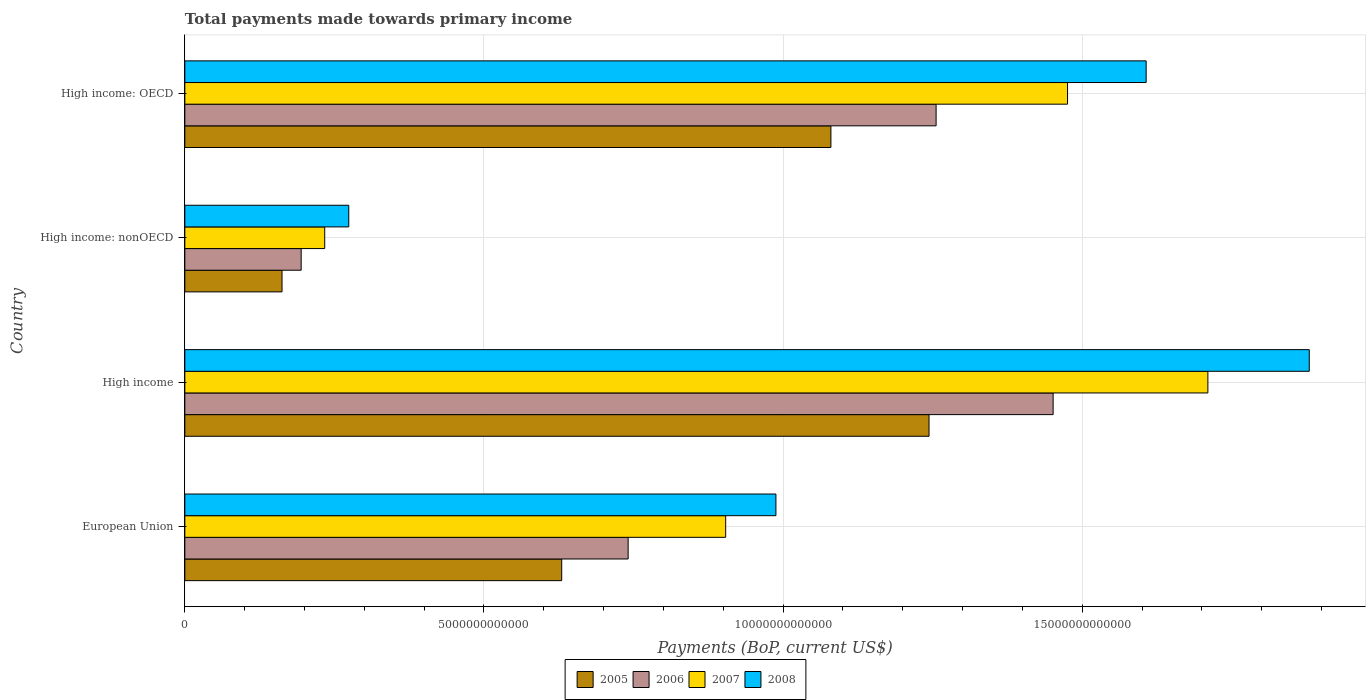How many different coloured bars are there?
Make the answer very short. 4. How many bars are there on the 3rd tick from the bottom?
Your answer should be compact. 4. What is the label of the 3rd group of bars from the top?
Your response must be concise. High income. What is the total payments made towards primary income in 2006 in High income: OECD?
Give a very brief answer. 1.26e+13. Across all countries, what is the maximum total payments made towards primary income in 2006?
Keep it short and to the point. 1.45e+13. Across all countries, what is the minimum total payments made towards primary income in 2008?
Ensure brevity in your answer.  2.74e+12. In which country was the total payments made towards primary income in 2007 minimum?
Make the answer very short. High income: nonOECD. What is the total total payments made towards primary income in 2005 in the graph?
Keep it short and to the point. 3.12e+13. What is the difference between the total payments made towards primary income in 2005 in European Union and that in High income: nonOECD?
Make the answer very short. 4.67e+12. What is the difference between the total payments made towards primary income in 2005 in High income: OECD and the total payments made towards primary income in 2008 in High income: nonOECD?
Offer a terse response. 8.06e+12. What is the average total payments made towards primary income in 2005 per country?
Ensure brevity in your answer.  7.79e+12. What is the difference between the total payments made towards primary income in 2006 and total payments made towards primary income in 2008 in European Union?
Provide a succinct answer. -2.47e+12. What is the ratio of the total payments made towards primary income in 2005 in European Union to that in High income?
Offer a very short reply. 0.51. Is the difference between the total payments made towards primary income in 2006 in High income and High income: OECD greater than the difference between the total payments made towards primary income in 2008 in High income and High income: OECD?
Your answer should be very brief. No. What is the difference between the highest and the second highest total payments made towards primary income in 2006?
Offer a very short reply. 1.96e+12. What is the difference between the highest and the lowest total payments made towards primary income in 2005?
Offer a very short reply. 1.08e+13. What does the 3rd bar from the bottom in High income represents?
Your response must be concise. 2007. How many bars are there?
Ensure brevity in your answer.  16. Are all the bars in the graph horizontal?
Provide a short and direct response. Yes. What is the difference between two consecutive major ticks on the X-axis?
Provide a short and direct response. 5.00e+12. Does the graph contain any zero values?
Your answer should be compact. No. Does the graph contain grids?
Your answer should be very brief. Yes. How are the legend labels stacked?
Offer a very short reply. Horizontal. What is the title of the graph?
Provide a succinct answer. Total payments made towards primary income. What is the label or title of the X-axis?
Give a very brief answer. Payments (BoP, current US$). What is the label or title of the Y-axis?
Your answer should be compact. Country. What is the Payments (BoP, current US$) of 2005 in European Union?
Your response must be concise. 6.30e+12. What is the Payments (BoP, current US$) of 2006 in European Union?
Keep it short and to the point. 7.41e+12. What is the Payments (BoP, current US$) in 2007 in European Union?
Provide a succinct answer. 9.04e+12. What is the Payments (BoP, current US$) in 2008 in European Union?
Your response must be concise. 9.88e+12. What is the Payments (BoP, current US$) of 2005 in High income?
Offer a terse response. 1.24e+13. What is the Payments (BoP, current US$) in 2006 in High income?
Make the answer very short. 1.45e+13. What is the Payments (BoP, current US$) in 2007 in High income?
Provide a succinct answer. 1.71e+13. What is the Payments (BoP, current US$) of 2008 in High income?
Ensure brevity in your answer.  1.88e+13. What is the Payments (BoP, current US$) in 2005 in High income: nonOECD?
Your response must be concise. 1.62e+12. What is the Payments (BoP, current US$) in 2006 in High income: nonOECD?
Your response must be concise. 1.94e+12. What is the Payments (BoP, current US$) in 2007 in High income: nonOECD?
Keep it short and to the point. 2.34e+12. What is the Payments (BoP, current US$) of 2008 in High income: nonOECD?
Your answer should be compact. 2.74e+12. What is the Payments (BoP, current US$) in 2005 in High income: OECD?
Provide a succinct answer. 1.08e+13. What is the Payments (BoP, current US$) in 2006 in High income: OECD?
Your answer should be compact. 1.26e+13. What is the Payments (BoP, current US$) in 2007 in High income: OECD?
Your answer should be compact. 1.48e+13. What is the Payments (BoP, current US$) of 2008 in High income: OECD?
Your answer should be very brief. 1.61e+13. Across all countries, what is the maximum Payments (BoP, current US$) in 2005?
Your response must be concise. 1.24e+13. Across all countries, what is the maximum Payments (BoP, current US$) in 2006?
Ensure brevity in your answer.  1.45e+13. Across all countries, what is the maximum Payments (BoP, current US$) in 2007?
Make the answer very short. 1.71e+13. Across all countries, what is the maximum Payments (BoP, current US$) in 2008?
Ensure brevity in your answer.  1.88e+13. Across all countries, what is the minimum Payments (BoP, current US$) of 2005?
Give a very brief answer. 1.62e+12. Across all countries, what is the minimum Payments (BoP, current US$) in 2006?
Offer a very short reply. 1.94e+12. Across all countries, what is the minimum Payments (BoP, current US$) of 2007?
Offer a very short reply. 2.34e+12. Across all countries, what is the minimum Payments (BoP, current US$) in 2008?
Your answer should be compact. 2.74e+12. What is the total Payments (BoP, current US$) of 2005 in the graph?
Keep it short and to the point. 3.12e+13. What is the total Payments (BoP, current US$) in 2006 in the graph?
Provide a short and direct response. 3.64e+13. What is the total Payments (BoP, current US$) in 2007 in the graph?
Provide a short and direct response. 4.32e+13. What is the total Payments (BoP, current US$) in 2008 in the graph?
Your answer should be compact. 4.75e+13. What is the difference between the Payments (BoP, current US$) of 2005 in European Union and that in High income?
Keep it short and to the point. -6.14e+12. What is the difference between the Payments (BoP, current US$) in 2006 in European Union and that in High income?
Offer a very short reply. -7.10e+12. What is the difference between the Payments (BoP, current US$) in 2007 in European Union and that in High income?
Your response must be concise. -8.06e+12. What is the difference between the Payments (BoP, current US$) of 2008 in European Union and that in High income?
Keep it short and to the point. -8.91e+12. What is the difference between the Payments (BoP, current US$) of 2005 in European Union and that in High income: nonOECD?
Your answer should be very brief. 4.67e+12. What is the difference between the Payments (BoP, current US$) of 2006 in European Union and that in High income: nonOECD?
Provide a succinct answer. 5.47e+12. What is the difference between the Payments (BoP, current US$) in 2007 in European Union and that in High income: nonOECD?
Offer a terse response. 6.70e+12. What is the difference between the Payments (BoP, current US$) in 2008 in European Union and that in High income: nonOECD?
Offer a very short reply. 7.14e+12. What is the difference between the Payments (BoP, current US$) in 2005 in European Union and that in High income: OECD?
Provide a succinct answer. -4.50e+12. What is the difference between the Payments (BoP, current US$) of 2006 in European Union and that in High income: OECD?
Give a very brief answer. -5.15e+12. What is the difference between the Payments (BoP, current US$) of 2007 in European Union and that in High income: OECD?
Keep it short and to the point. -5.71e+12. What is the difference between the Payments (BoP, current US$) of 2008 in European Union and that in High income: OECD?
Your response must be concise. -6.19e+12. What is the difference between the Payments (BoP, current US$) in 2005 in High income and that in High income: nonOECD?
Ensure brevity in your answer.  1.08e+13. What is the difference between the Payments (BoP, current US$) of 2006 in High income and that in High income: nonOECD?
Provide a short and direct response. 1.26e+13. What is the difference between the Payments (BoP, current US$) in 2007 in High income and that in High income: nonOECD?
Offer a very short reply. 1.48e+13. What is the difference between the Payments (BoP, current US$) in 2008 in High income and that in High income: nonOECD?
Keep it short and to the point. 1.61e+13. What is the difference between the Payments (BoP, current US$) of 2005 in High income and that in High income: OECD?
Your answer should be very brief. 1.64e+12. What is the difference between the Payments (BoP, current US$) of 2006 in High income and that in High income: OECD?
Make the answer very short. 1.96e+12. What is the difference between the Payments (BoP, current US$) in 2007 in High income and that in High income: OECD?
Give a very brief answer. 2.35e+12. What is the difference between the Payments (BoP, current US$) in 2008 in High income and that in High income: OECD?
Provide a short and direct response. 2.73e+12. What is the difference between the Payments (BoP, current US$) of 2005 in High income: nonOECD and that in High income: OECD?
Your response must be concise. -9.17e+12. What is the difference between the Payments (BoP, current US$) in 2006 in High income: nonOECD and that in High income: OECD?
Provide a succinct answer. -1.06e+13. What is the difference between the Payments (BoP, current US$) of 2007 in High income: nonOECD and that in High income: OECD?
Make the answer very short. -1.24e+13. What is the difference between the Payments (BoP, current US$) in 2008 in High income: nonOECD and that in High income: OECD?
Your answer should be compact. -1.33e+13. What is the difference between the Payments (BoP, current US$) of 2005 in European Union and the Payments (BoP, current US$) of 2006 in High income?
Ensure brevity in your answer.  -8.21e+12. What is the difference between the Payments (BoP, current US$) of 2005 in European Union and the Payments (BoP, current US$) of 2007 in High income?
Keep it short and to the point. -1.08e+13. What is the difference between the Payments (BoP, current US$) of 2005 in European Union and the Payments (BoP, current US$) of 2008 in High income?
Offer a very short reply. -1.25e+13. What is the difference between the Payments (BoP, current US$) in 2006 in European Union and the Payments (BoP, current US$) in 2007 in High income?
Offer a terse response. -9.69e+12. What is the difference between the Payments (BoP, current US$) in 2006 in European Union and the Payments (BoP, current US$) in 2008 in High income?
Your answer should be very brief. -1.14e+13. What is the difference between the Payments (BoP, current US$) in 2007 in European Union and the Payments (BoP, current US$) in 2008 in High income?
Offer a very short reply. -9.75e+12. What is the difference between the Payments (BoP, current US$) in 2005 in European Union and the Payments (BoP, current US$) in 2006 in High income: nonOECD?
Your answer should be very brief. 4.35e+12. What is the difference between the Payments (BoP, current US$) of 2005 in European Union and the Payments (BoP, current US$) of 2007 in High income: nonOECD?
Give a very brief answer. 3.96e+12. What is the difference between the Payments (BoP, current US$) in 2005 in European Union and the Payments (BoP, current US$) in 2008 in High income: nonOECD?
Offer a terse response. 3.56e+12. What is the difference between the Payments (BoP, current US$) in 2006 in European Union and the Payments (BoP, current US$) in 2007 in High income: nonOECD?
Ensure brevity in your answer.  5.07e+12. What is the difference between the Payments (BoP, current US$) of 2006 in European Union and the Payments (BoP, current US$) of 2008 in High income: nonOECD?
Ensure brevity in your answer.  4.67e+12. What is the difference between the Payments (BoP, current US$) of 2007 in European Union and the Payments (BoP, current US$) of 2008 in High income: nonOECD?
Make the answer very short. 6.30e+12. What is the difference between the Payments (BoP, current US$) of 2005 in European Union and the Payments (BoP, current US$) of 2006 in High income: OECD?
Your answer should be compact. -6.26e+12. What is the difference between the Payments (BoP, current US$) of 2005 in European Union and the Payments (BoP, current US$) of 2007 in High income: OECD?
Offer a very short reply. -8.45e+12. What is the difference between the Payments (BoP, current US$) in 2005 in European Union and the Payments (BoP, current US$) in 2008 in High income: OECD?
Provide a short and direct response. -9.77e+12. What is the difference between the Payments (BoP, current US$) in 2006 in European Union and the Payments (BoP, current US$) in 2007 in High income: OECD?
Give a very brief answer. -7.34e+12. What is the difference between the Payments (BoP, current US$) of 2006 in European Union and the Payments (BoP, current US$) of 2008 in High income: OECD?
Offer a terse response. -8.66e+12. What is the difference between the Payments (BoP, current US$) in 2007 in European Union and the Payments (BoP, current US$) in 2008 in High income: OECD?
Your response must be concise. -7.03e+12. What is the difference between the Payments (BoP, current US$) in 2005 in High income and the Payments (BoP, current US$) in 2006 in High income: nonOECD?
Keep it short and to the point. 1.05e+13. What is the difference between the Payments (BoP, current US$) of 2005 in High income and the Payments (BoP, current US$) of 2007 in High income: nonOECD?
Offer a very short reply. 1.01e+13. What is the difference between the Payments (BoP, current US$) in 2005 in High income and the Payments (BoP, current US$) in 2008 in High income: nonOECD?
Your response must be concise. 9.70e+12. What is the difference between the Payments (BoP, current US$) of 2006 in High income and the Payments (BoP, current US$) of 2007 in High income: nonOECD?
Provide a short and direct response. 1.22e+13. What is the difference between the Payments (BoP, current US$) of 2006 in High income and the Payments (BoP, current US$) of 2008 in High income: nonOECD?
Make the answer very short. 1.18e+13. What is the difference between the Payments (BoP, current US$) in 2007 in High income and the Payments (BoP, current US$) in 2008 in High income: nonOECD?
Provide a short and direct response. 1.44e+13. What is the difference between the Payments (BoP, current US$) of 2005 in High income and the Payments (BoP, current US$) of 2006 in High income: OECD?
Provide a short and direct response. -1.18e+11. What is the difference between the Payments (BoP, current US$) in 2005 in High income and the Payments (BoP, current US$) in 2007 in High income: OECD?
Keep it short and to the point. -2.32e+12. What is the difference between the Payments (BoP, current US$) in 2005 in High income and the Payments (BoP, current US$) in 2008 in High income: OECD?
Provide a short and direct response. -3.63e+12. What is the difference between the Payments (BoP, current US$) of 2006 in High income and the Payments (BoP, current US$) of 2007 in High income: OECD?
Your answer should be compact. -2.41e+11. What is the difference between the Payments (BoP, current US$) of 2006 in High income and the Payments (BoP, current US$) of 2008 in High income: OECD?
Your answer should be compact. -1.55e+12. What is the difference between the Payments (BoP, current US$) in 2007 in High income and the Payments (BoP, current US$) in 2008 in High income: OECD?
Give a very brief answer. 1.03e+12. What is the difference between the Payments (BoP, current US$) in 2005 in High income: nonOECD and the Payments (BoP, current US$) in 2006 in High income: OECD?
Your answer should be compact. -1.09e+13. What is the difference between the Payments (BoP, current US$) in 2005 in High income: nonOECD and the Payments (BoP, current US$) in 2007 in High income: OECD?
Offer a very short reply. -1.31e+13. What is the difference between the Payments (BoP, current US$) in 2005 in High income: nonOECD and the Payments (BoP, current US$) in 2008 in High income: OECD?
Your answer should be compact. -1.44e+13. What is the difference between the Payments (BoP, current US$) of 2006 in High income: nonOECD and the Payments (BoP, current US$) of 2007 in High income: OECD?
Give a very brief answer. -1.28e+13. What is the difference between the Payments (BoP, current US$) of 2006 in High income: nonOECD and the Payments (BoP, current US$) of 2008 in High income: OECD?
Ensure brevity in your answer.  -1.41e+13. What is the difference between the Payments (BoP, current US$) in 2007 in High income: nonOECD and the Payments (BoP, current US$) in 2008 in High income: OECD?
Make the answer very short. -1.37e+13. What is the average Payments (BoP, current US$) of 2005 per country?
Offer a terse response. 7.79e+12. What is the average Payments (BoP, current US$) in 2006 per country?
Your response must be concise. 9.11e+12. What is the average Payments (BoP, current US$) of 2007 per country?
Your answer should be compact. 1.08e+13. What is the average Payments (BoP, current US$) of 2008 per country?
Make the answer very short. 1.19e+13. What is the difference between the Payments (BoP, current US$) in 2005 and Payments (BoP, current US$) in 2006 in European Union?
Your answer should be very brief. -1.11e+12. What is the difference between the Payments (BoP, current US$) in 2005 and Payments (BoP, current US$) in 2007 in European Union?
Your answer should be compact. -2.74e+12. What is the difference between the Payments (BoP, current US$) of 2005 and Payments (BoP, current US$) of 2008 in European Union?
Your answer should be compact. -3.58e+12. What is the difference between the Payments (BoP, current US$) of 2006 and Payments (BoP, current US$) of 2007 in European Union?
Provide a succinct answer. -1.63e+12. What is the difference between the Payments (BoP, current US$) in 2006 and Payments (BoP, current US$) in 2008 in European Union?
Keep it short and to the point. -2.47e+12. What is the difference between the Payments (BoP, current US$) of 2007 and Payments (BoP, current US$) of 2008 in European Union?
Provide a succinct answer. -8.40e+11. What is the difference between the Payments (BoP, current US$) in 2005 and Payments (BoP, current US$) in 2006 in High income?
Keep it short and to the point. -2.07e+12. What is the difference between the Payments (BoP, current US$) in 2005 and Payments (BoP, current US$) in 2007 in High income?
Make the answer very short. -4.66e+12. What is the difference between the Payments (BoP, current US$) of 2005 and Payments (BoP, current US$) of 2008 in High income?
Your response must be concise. -6.36e+12. What is the difference between the Payments (BoP, current US$) of 2006 and Payments (BoP, current US$) of 2007 in High income?
Give a very brief answer. -2.59e+12. What is the difference between the Payments (BoP, current US$) of 2006 and Payments (BoP, current US$) of 2008 in High income?
Provide a succinct answer. -4.28e+12. What is the difference between the Payments (BoP, current US$) in 2007 and Payments (BoP, current US$) in 2008 in High income?
Offer a terse response. -1.69e+12. What is the difference between the Payments (BoP, current US$) of 2005 and Payments (BoP, current US$) of 2006 in High income: nonOECD?
Your answer should be compact. -3.20e+11. What is the difference between the Payments (BoP, current US$) of 2005 and Payments (BoP, current US$) of 2007 in High income: nonOECD?
Keep it short and to the point. -7.13e+11. What is the difference between the Payments (BoP, current US$) of 2005 and Payments (BoP, current US$) of 2008 in High income: nonOECD?
Provide a short and direct response. -1.12e+12. What is the difference between the Payments (BoP, current US$) of 2006 and Payments (BoP, current US$) of 2007 in High income: nonOECD?
Give a very brief answer. -3.94e+11. What is the difference between the Payments (BoP, current US$) of 2006 and Payments (BoP, current US$) of 2008 in High income: nonOECD?
Make the answer very short. -7.96e+11. What is the difference between the Payments (BoP, current US$) of 2007 and Payments (BoP, current US$) of 2008 in High income: nonOECD?
Keep it short and to the point. -4.02e+11. What is the difference between the Payments (BoP, current US$) in 2005 and Payments (BoP, current US$) in 2006 in High income: OECD?
Your answer should be compact. -1.76e+12. What is the difference between the Payments (BoP, current US$) in 2005 and Payments (BoP, current US$) in 2007 in High income: OECD?
Offer a terse response. -3.96e+12. What is the difference between the Payments (BoP, current US$) of 2005 and Payments (BoP, current US$) of 2008 in High income: OECD?
Make the answer very short. -5.27e+12. What is the difference between the Payments (BoP, current US$) of 2006 and Payments (BoP, current US$) of 2007 in High income: OECD?
Keep it short and to the point. -2.20e+12. What is the difference between the Payments (BoP, current US$) in 2006 and Payments (BoP, current US$) in 2008 in High income: OECD?
Make the answer very short. -3.51e+12. What is the difference between the Payments (BoP, current US$) in 2007 and Payments (BoP, current US$) in 2008 in High income: OECD?
Provide a short and direct response. -1.31e+12. What is the ratio of the Payments (BoP, current US$) of 2005 in European Union to that in High income?
Provide a short and direct response. 0.51. What is the ratio of the Payments (BoP, current US$) of 2006 in European Union to that in High income?
Offer a very short reply. 0.51. What is the ratio of the Payments (BoP, current US$) in 2007 in European Union to that in High income?
Offer a very short reply. 0.53. What is the ratio of the Payments (BoP, current US$) of 2008 in European Union to that in High income?
Give a very brief answer. 0.53. What is the ratio of the Payments (BoP, current US$) in 2005 in European Union to that in High income: nonOECD?
Give a very brief answer. 3.88. What is the ratio of the Payments (BoP, current US$) in 2006 in European Union to that in High income: nonOECD?
Your answer should be compact. 3.81. What is the ratio of the Payments (BoP, current US$) of 2007 in European Union to that in High income: nonOECD?
Give a very brief answer. 3.87. What is the ratio of the Payments (BoP, current US$) of 2008 in European Union to that in High income: nonOECD?
Give a very brief answer. 3.61. What is the ratio of the Payments (BoP, current US$) in 2005 in European Union to that in High income: OECD?
Offer a terse response. 0.58. What is the ratio of the Payments (BoP, current US$) of 2006 in European Union to that in High income: OECD?
Give a very brief answer. 0.59. What is the ratio of the Payments (BoP, current US$) of 2007 in European Union to that in High income: OECD?
Provide a succinct answer. 0.61. What is the ratio of the Payments (BoP, current US$) in 2008 in European Union to that in High income: OECD?
Provide a short and direct response. 0.61. What is the ratio of the Payments (BoP, current US$) in 2005 in High income to that in High income: nonOECD?
Offer a very short reply. 7.66. What is the ratio of the Payments (BoP, current US$) of 2006 in High income to that in High income: nonOECD?
Your answer should be compact. 7.46. What is the ratio of the Payments (BoP, current US$) of 2007 in High income to that in High income: nonOECD?
Make the answer very short. 7.31. What is the ratio of the Payments (BoP, current US$) in 2008 in High income to that in High income: nonOECD?
Offer a terse response. 6.86. What is the ratio of the Payments (BoP, current US$) of 2005 in High income to that in High income: OECD?
Provide a short and direct response. 1.15. What is the ratio of the Payments (BoP, current US$) in 2006 in High income to that in High income: OECD?
Make the answer very short. 1.16. What is the ratio of the Payments (BoP, current US$) of 2007 in High income to that in High income: OECD?
Your answer should be very brief. 1.16. What is the ratio of the Payments (BoP, current US$) of 2008 in High income to that in High income: OECD?
Give a very brief answer. 1.17. What is the ratio of the Payments (BoP, current US$) in 2005 in High income: nonOECD to that in High income: OECD?
Provide a short and direct response. 0.15. What is the ratio of the Payments (BoP, current US$) of 2006 in High income: nonOECD to that in High income: OECD?
Your answer should be compact. 0.15. What is the ratio of the Payments (BoP, current US$) of 2007 in High income: nonOECD to that in High income: OECD?
Provide a short and direct response. 0.16. What is the ratio of the Payments (BoP, current US$) in 2008 in High income: nonOECD to that in High income: OECD?
Keep it short and to the point. 0.17. What is the difference between the highest and the second highest Payments (BoP, current US$) in 2005?
Your answer should be compact. 1.64e+12. What is the difference between the highest and the second highest Payments (BoP, current US$) of 2006?
Ensure brevity in your answer.  1.96e+12. What is the difference between the highest and the second highest Payments (BoP, current US$) in 2007?
Provide a succinct answer. 2.35e+12. What is the difference between the highest and the second highest Payments (BoP, current US$) of 2008?
Your response must be concise. 2.73e+12. What is the difference between the highest and the lowest Payments (BoP, current US$) in 2005?
Provide a succinct answer. 1.08e+13. What is the difference between the highest and the lowest Payments (BoP, current US$) of 2006?
Make the answer very short. 1.26e+13. What is the difference between the highest and the lowest Payments (BoP, current US$) in 2007?
Offer a terse response. 1.48e+13. What is the difference between the highest and the lowest Payments (BoP, current US$) in 2008?
Keep it short and to the point. 1.61e+13. 